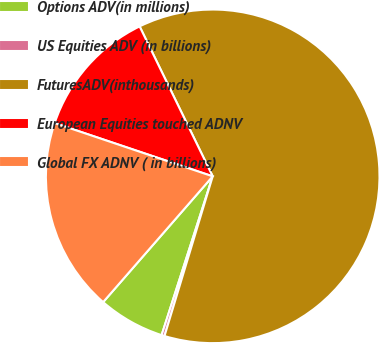Convert chart. <chart><loc_0><loc_0><loc_500><loc_500><pie_chart><fcel>Options ADV(in millions)<fcel>US Equities ADV (in billions)<fcel>FuturesADV(inthousands)<fcel>European Equities touched ADNV<fcel>Global FX ADNV ( in billions)<nl><fcel>6.45%<fcel>0.29%<fcel>61.89%<fcel>12.61%<fcel>18.77%<nl></chart> 